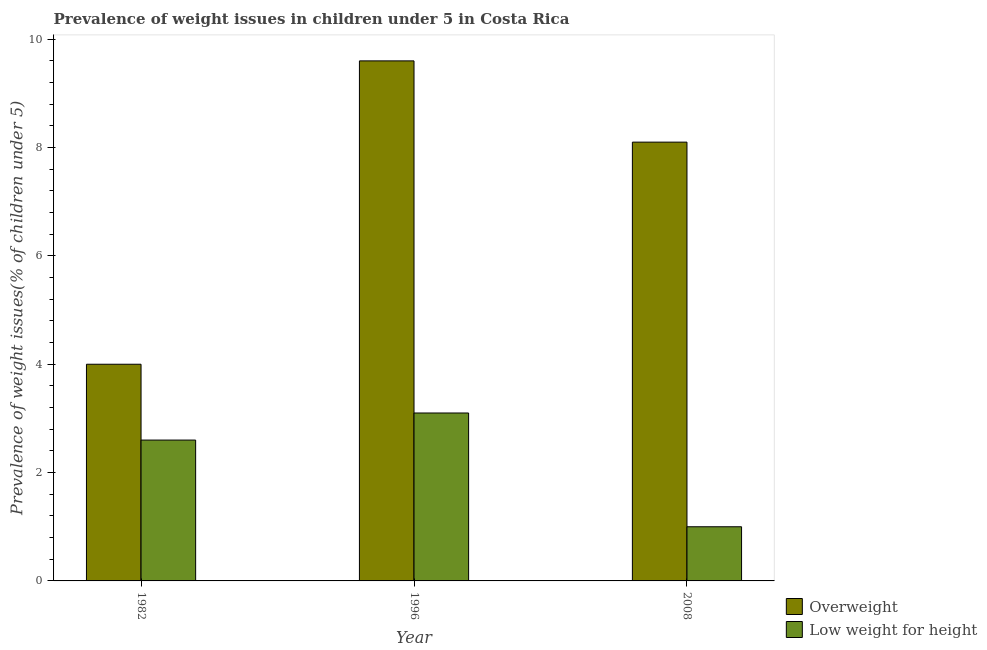Are the number of bars per tick equal to the number of legend labels?
Keep it short and to the point. Yes. In how many cases, is the number of bars for a given year not equal to the number of legend labels?
Offer a terse response. 0. What is the percentage of underweight children in 2008?
Offer a very short reply. 1. Across all years, what is the maximum percentage of overweight children?
Ensure brevity in your answer.  9.6. Across all years, what is the minimum percentage of underweight children?
Keep it short and to the point. 1. What is the total percentage of underweight children in the graph?
Offer a very short reply. 6.7. What is the average percentage of underweight children per year?
Your response must be concise. 2.23. In how many years, is the percentage of underweight children greater than 1.2000000000000002 %?
Your response must be concise. 2. What is the ratio of the percentage of overweight children in 1982 to that in 1996?
Give a very brief answer. 0.42. Is the percentage of overweight children in 1982 less than that in 1996?
Keep it short and to the point. Yes. What is the difference between the highest and the second highest percentage of underweight children?
Give a very brief answer. 0.5. What is the difference between the highest and the lowest percentage of underweight children?
Offer a terse response. 2.1. In how many years, is the percentage of underweight children greater than the average percentage of underweight children taken over all years?
Offer a terse response. 2. Is the sum of the percentage of overweight children in 1982 and 2008 greater than the maximum percentage of underweight children across all years?
Your answer should be compact. Yes. What does the 2nd bar from the left in 1996 represents?
Make the answer very short. Low weight for height. What does the 1st bar from the right in 2008 represents?
Make the answer very short. Low weight for height. How many legend labels are there?
Provide a short and direct response. 2. How are the legend labels stacked?
Provide a short and direct response. Vertical. What is the title of the graph?
Offer a terse response. Prevalence of weight issues in children under 5 in Costa Rica. What is the label or title of the X-axis?
Ensure brevity in your answer.  Year. What is the label or title of the Y-axis?
Make the answer very short. Prevalence of weight issues(% of children under 5). What is the Prevalence of weight issues(% of children under 5) of Overweight in 1982?
Keep it short and to the point. 4. What is the Prevalence of weight issues(% of children under 5) in Low weight for height in 1982?
Your response must be concise. 2.6. What is the Prevalence of weight issues(% of children under 5) of Overweight in 1996?
Your answer should be compact. 9.6. What is the Prevalence of weight issues(% of children under 5) in Low weight for height in 1996?
Offer a very short reply. 3.1. What is the Prevalence of weight issues(% of children under 5) in Overweight in 2008?
Your answer should be compact. 8.1. Across all years, what is the maximum Prevalence of weight issues(% of children under 5) of Overweight?
Your response must be concise. 9.6. Across all years, what is the maximum Prevalence of weight issues(% of children under 5) in Low weight for height?
Provide a short and direct response. 3.1. What is the total Prevalence of weight issues(% of children under 5) in Overweight in the graph?
Keep it short and to the point. 21.7. What is the difference between the Prevalence of weight issues(% of children under 5) of Overweight in 1982 and that in 2008?
Keep it short and to the point. -4.1. What is the difference between the Prevalence of weight issues(% of children under 5) in Overweight in 1982 and the Prevalence of weight issues(% of children under 5) in Low weight for height in 2008?
Provide a succinct answer. 3. What is the difference between the Prevalence of weight issues(% of children under 5) in Overweight in 1996 and the Prevalence of weight issues(% of children under 5) in Low weight for height in 2008?
Make the answer very short. 8.6. What is the average Prevalence of weight issues(% of children under 5) of Overweight per year?
Your response must be concise. 7.23. What is the average Prevalence of weight issues(% of children under 5) of Low weight for height per year?
Your response must be concise. 2.23. In the year 1996, what is the difference between the Prevalence of weight issues(% of children under 5) in Overweight and Prevalence of weight issues(% of children under 5) in Low weight for height?
Your response must be concise. 6.5. In the year 2008, what is the difference between the Prevalence of weight issues(% of children under 5) in Overweight and Prevalence of weight issues(% of children under 5) in Low weight for height?
Ensure brevity in your answer.  7.1. What is the ratio of the Prevalence of weight issues(% of children under 5) of Overweight in 1982 to that in 1996?
Provide a short and direct response. 0.42. What is the ratio of the Prevalence of weight issues(% of children under 5) in Low weight for height in 1982 to that in 1996?
Offer a very short reply. 0.84. What is the ratio of the Prevalence of weight issues(% of children under 5) of Overweight in 1982 to that in 2008?
Your answer should be very brief. 0.49. What is the ratio of the Prevalence of weight issues(% of children under 5) in Low weight for height in 1982 to that in 2008?
Offer a terse response. 2.6. What is the ratio of the Prevalence of weight issues(% of children under 5) of Overweight in 1996 to that in 2008?
Provide a short and direct response. 1.19. What is the ratio of the Prevalence of weight issues(% of children under 5) in Low weight for height in 1996 to that in 2008?
Provide a succinct answer. 3.1. What is the difference between the highest and the second highest Prevalence of weight issues(% of children under 5) in Overweight?
Offer a terse response. 1.5. What is the difference between the highest and the second highest Prevalence of weight issues(% of children under 5) in Low weight for height?
Make the answer very short. 0.5. What is the difference between the highest and the lowest Prevalence of weight issues(% of children under 5) in Overweight?
Your response must be concise. 5.6. What is the difference between the highest and the lowest Prevalence of weight issues(% of children under 5) of Low weight for height?
Make the answer very short. 2.1. 